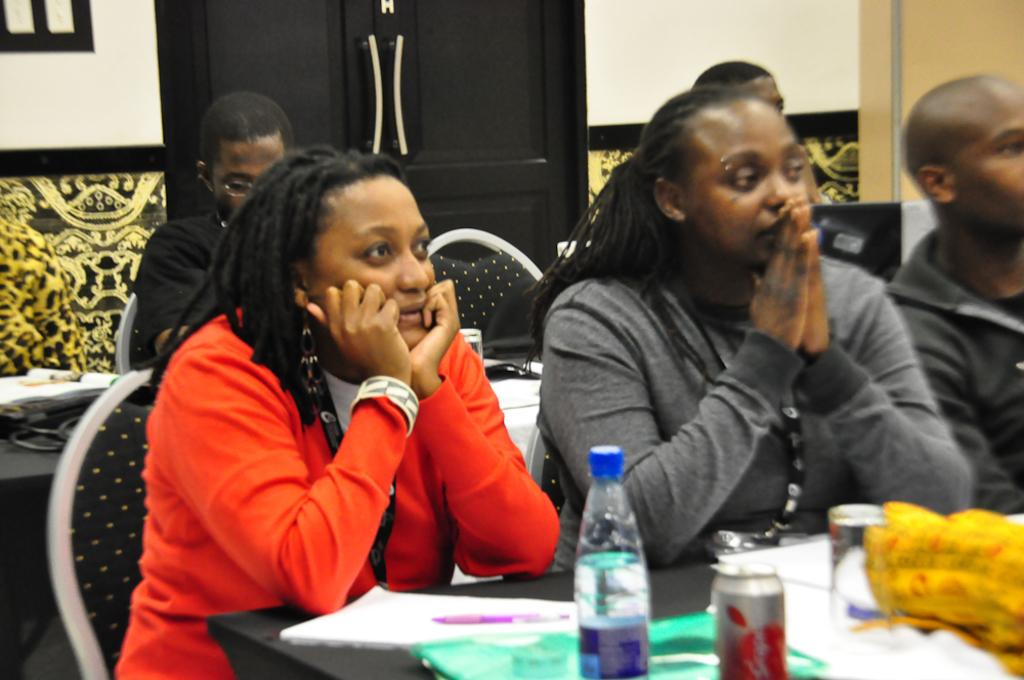What are the people in the image doing? The people in the image are sitting on chairs. What can be seen on the table in the image? There is a water bottle, a cold drink can, papers, and a pen on the table. What month is it in the image? The month cannot be determined from the image, as there is no information about the date or time of year. Can you see an arch in the image? There is no arch present in the image. 